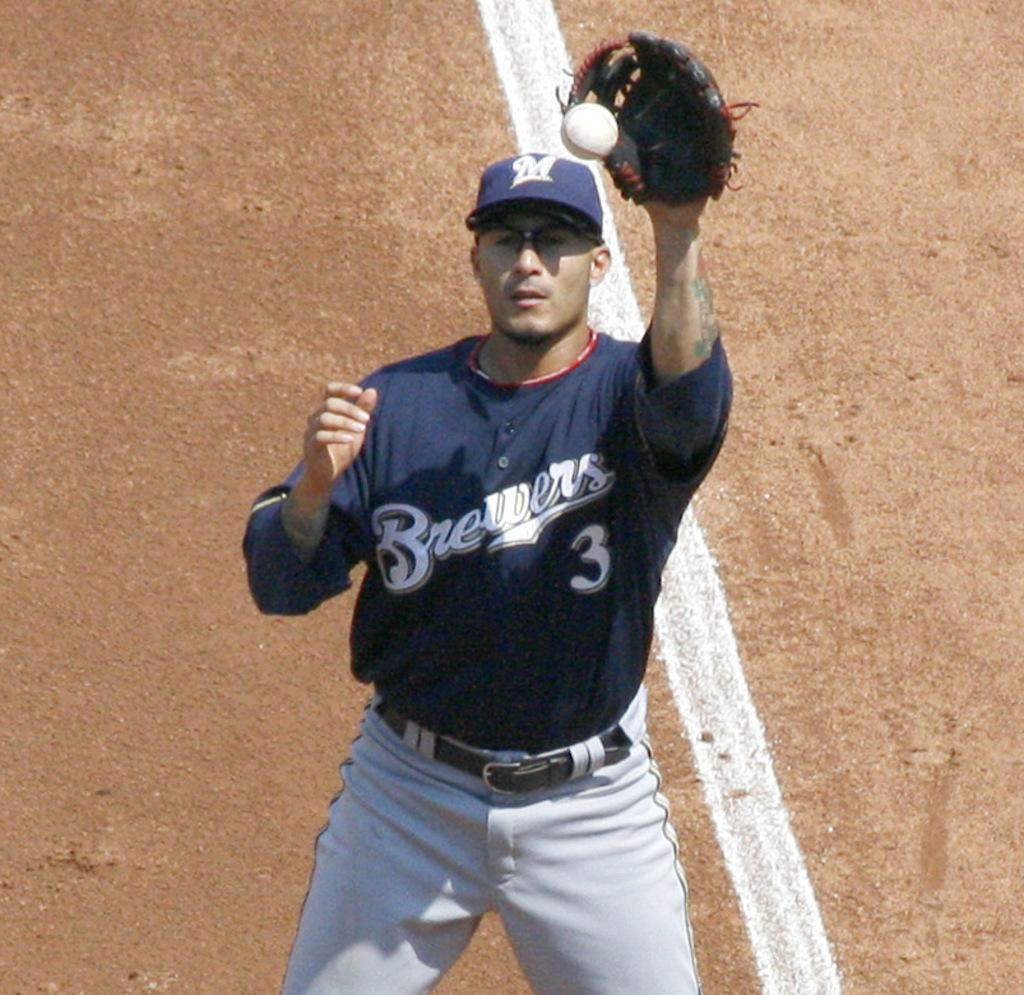<image>
Offer a succinct explanation of the picture presented. A baseball player catches the ball with a number 3 written on his top. 